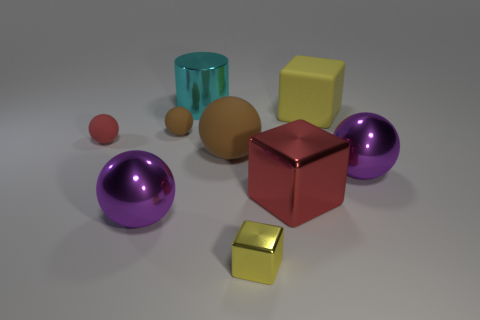Subtract all big rubber balls. How many balls are left? 4 Subtract 2 cubes. How many cubes are left? 1 Subtract all purple balls. How many balls are left? 3 Subtract all cylinders. How many objects are left? 8 Subtract all yellow balls. Subtract all yellow blocks. How many balls are left? 5 Subtract all brown cylinders. How many purple spheres are left? 2 Subtract all cylinders. Subtract all red matte things. How many objects are left? 7 Add 9 big red metallic cubes. How many big red metallic cubes are left? 10 Add 9 small red objects. How many small red objects exist? 10 Subtract 1 red balls. How many objects are left? 8 